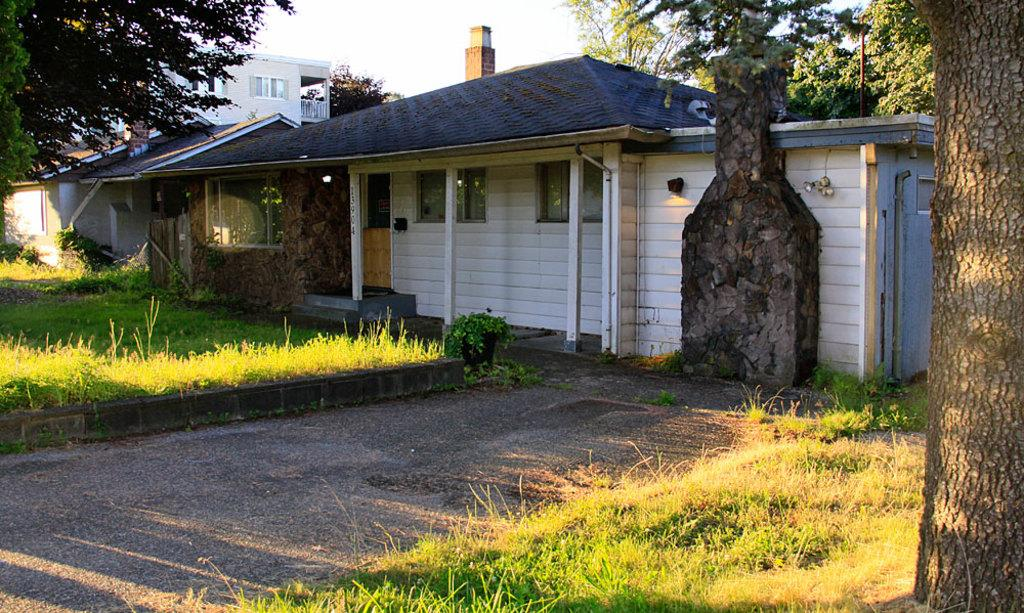What type of structure is visible in the image? There is a building in the image. What else can be seen in the image besides the building? There is a road, grass, a plant pot, trees, and a light visible in the image. Can you describe the color of the sky in the image? The sky is white in the image. What type of ink is being used to write on the shoe in the image? There is no shoe or ink present in the image. Can you describe the yak's behavior in the image? There is no yak present in the image. 